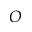<formula> <loc_0><loc_0><loc_500><loc_500>O</formula> 